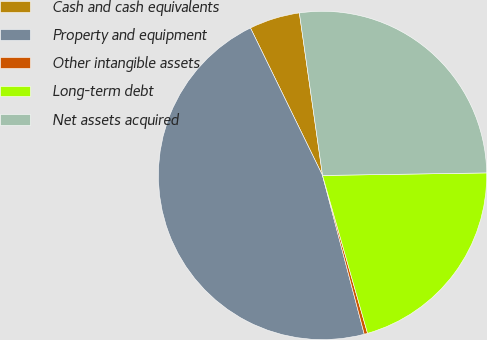Convert chart. <chart><loc_0><loc_0><loc_500><loc_500><pie_chart><fcel>Cash and cash equivalents<fcel>Property and equipment<fcel>Other intangible assets<fcel>Long-term debt<fcel>Net assets acquired<nl><fcel>4.98%<fcel>46.86%<fcel>0.33%<fcel>20.83%<fcel>27.01%<nl></chart> 